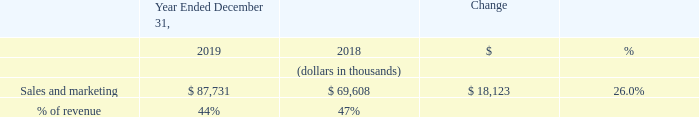Sales and Marketing Expense
Sales and marketing expense increased by $18.1 million in 2019 compared to 2018. The increase was primarily due to a $15.5 million increase in employee-related costs, which includes stock-based compensation, associated with our increased headcount from 286 employees as of December 31, 2018 to 345 employees as of December 31, 2019. The remaining increase was principally the result of a $1.2 million increase in trade show and advertising costs and a $1.0 million increase attributed to office related expenses to support the sales team.
What was the increase in the Sales and marketing expense in 2019? $18.1 million. What was increase in the trade show and advertising cost in 2019? $1.2 million. What was the % of revenue in 2019 and 2018?
Answer scale should be: percent. 44, 47. What was the average Sales and marketing expenses for 2018 and 2019?
Answer scale should be: thousand. (87,731 + 69,608) / 2
Answer: 78669.5. In which year was Sales and marketing expenses less than 90,000 thousands? Locate and analyze sales and marketing in row 4
answer: 2019, 2018. What is the change in the % of revenue from 2018 to 2019?
Answer scale should be: percent. 44 - 47
Answer: -3. 